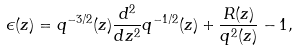Convert formula to latex. <formula><loc_0><loc_0><loc_500><loc_500>\epsilon ( z ) = q ^ { - 3 / 2 } ( z ) \frac { d ^ { 2 } } { d z ^ { 2 } } q ^ { - 1 / 2 } ( z ) + \frac { R ( z ) } { q ^ { 2 } ( z ) } - 1 ,</formula> 